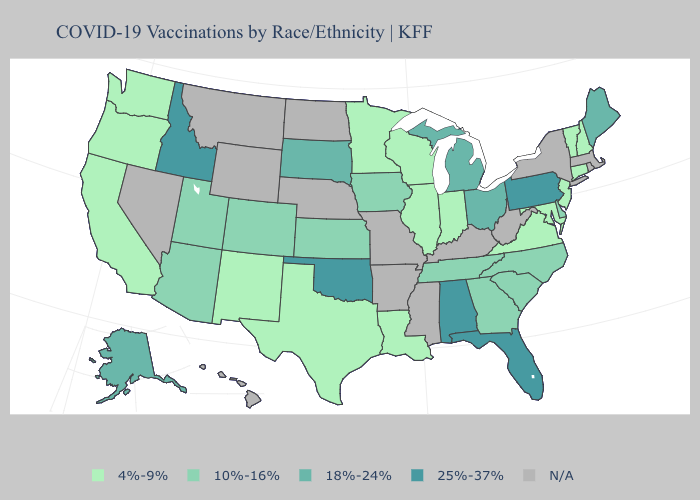How many symbols are there in the legend?
Write a very short answer. 5. Does the map have missing data?
Keep it brief. Yes. What is the highest value in states that border North Dakota?
Concise answer only. 18%-24%. Which states have the lowest value in the South?
Write a very short answer. Louisiana, Maryland, Texas, Virginia. What is the highest value in states that border Delaware?
Concise answer only. 25%-37%. Does the map have missing data?
Quick response, please. Yes. Among the states that border Tennessee , which have the highest value?
Concise answer only. Alabama. What is the lowest value in the South?
Answer briefly. 4%-9%. What is the value of Mississippi?
Concise answer only. N/A. What is the lowest value in states that border Iowa?
Give a very brief answer. 4%-9%. What is the value of Colorado?
Be succinct. 10%-16%. Which states have the highest value in the USA?
Concise answer only. Alabama, Florida, Idaho, Oklahoma, Pennsylvania. What is the value of Wisconsin?
Keep it brief. 4%-9%. What is the value of Nebraska?
Give a very brief answer. N/A. What is the lowest value in states that border Oregon?
Write a very short answer. 4%-9%. 